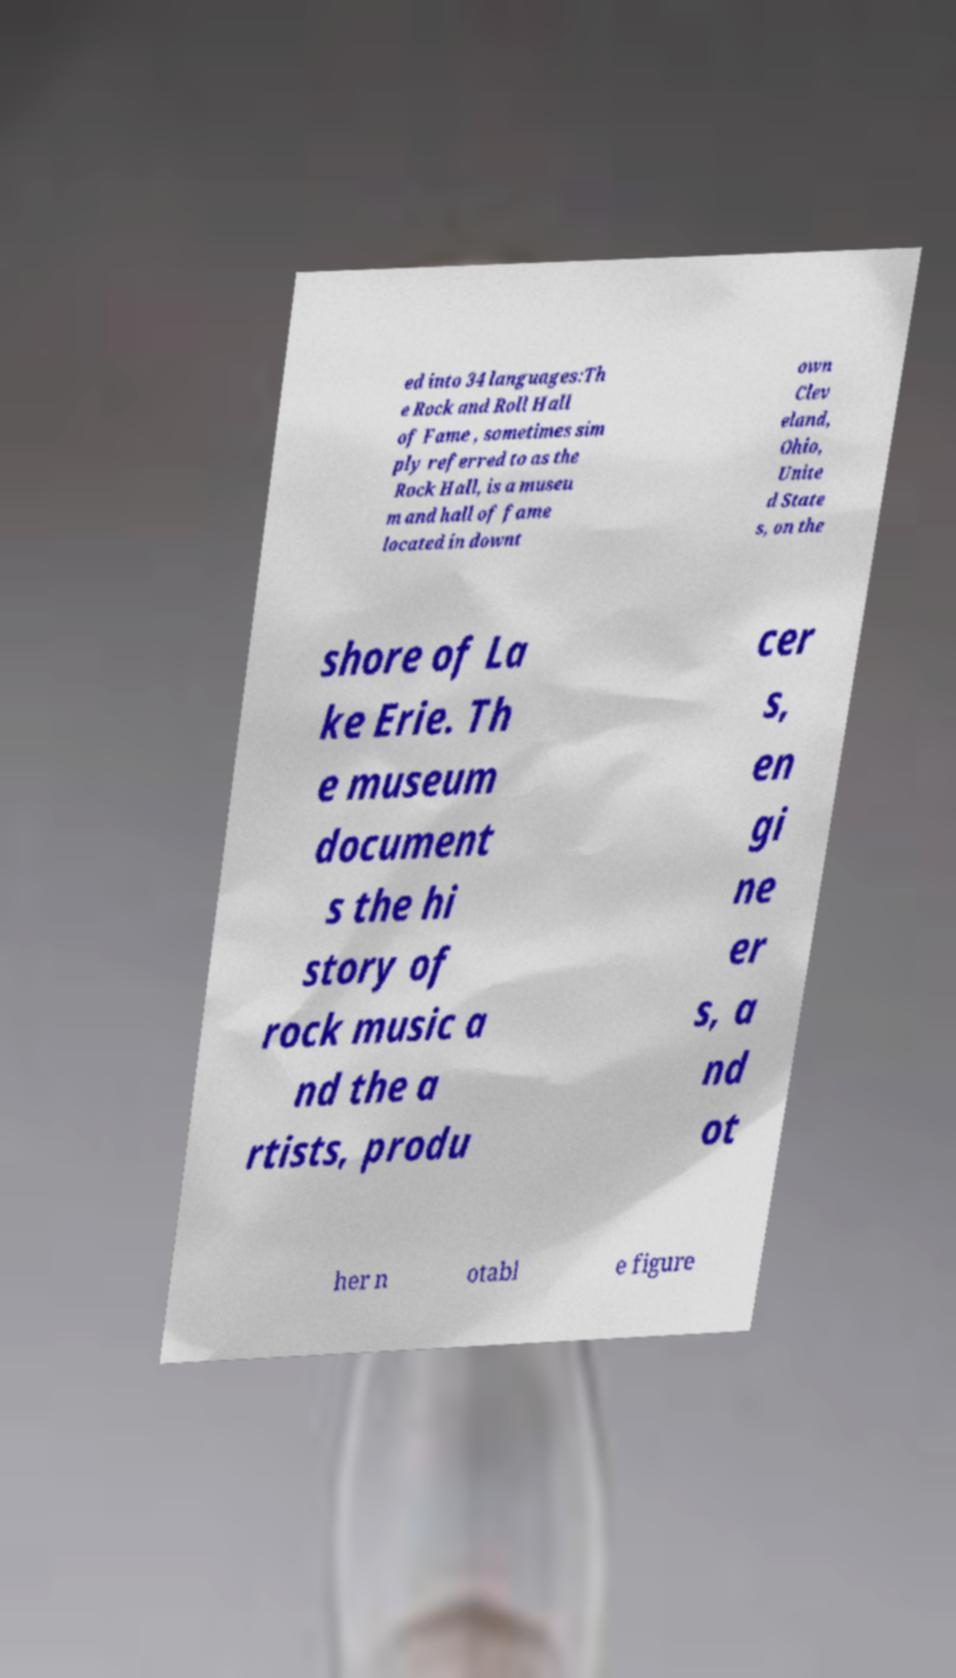I need the written content from this picture converted into text. Can you do that? ed into 34 languages:Th e Rock and Roll Hall of Fame , sometimes sim ply referred to as the Rock Hall, is a museu m and hall of fame located in downt own Clev eland, Ohio, Unite d State s, on the shore of La ke Erie. Th e museum document s the hi story of rock music a nd the a rtists, produ cer s, en gi ne er s, a nd ot her n otabl e figure 